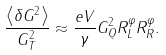<formula> <loc_0><loc_0><loc_500><loc_500>\frac { \left \langle \delta G ^ { 2 } \right \rangle } { G _ { T } ^ { 2 } } \approx \frac { e V } \gamma G _ { Q } ^ { 2 } R _ { L } ^ { \varphi } R _ { R } ^ { \varphi } .</formula> 